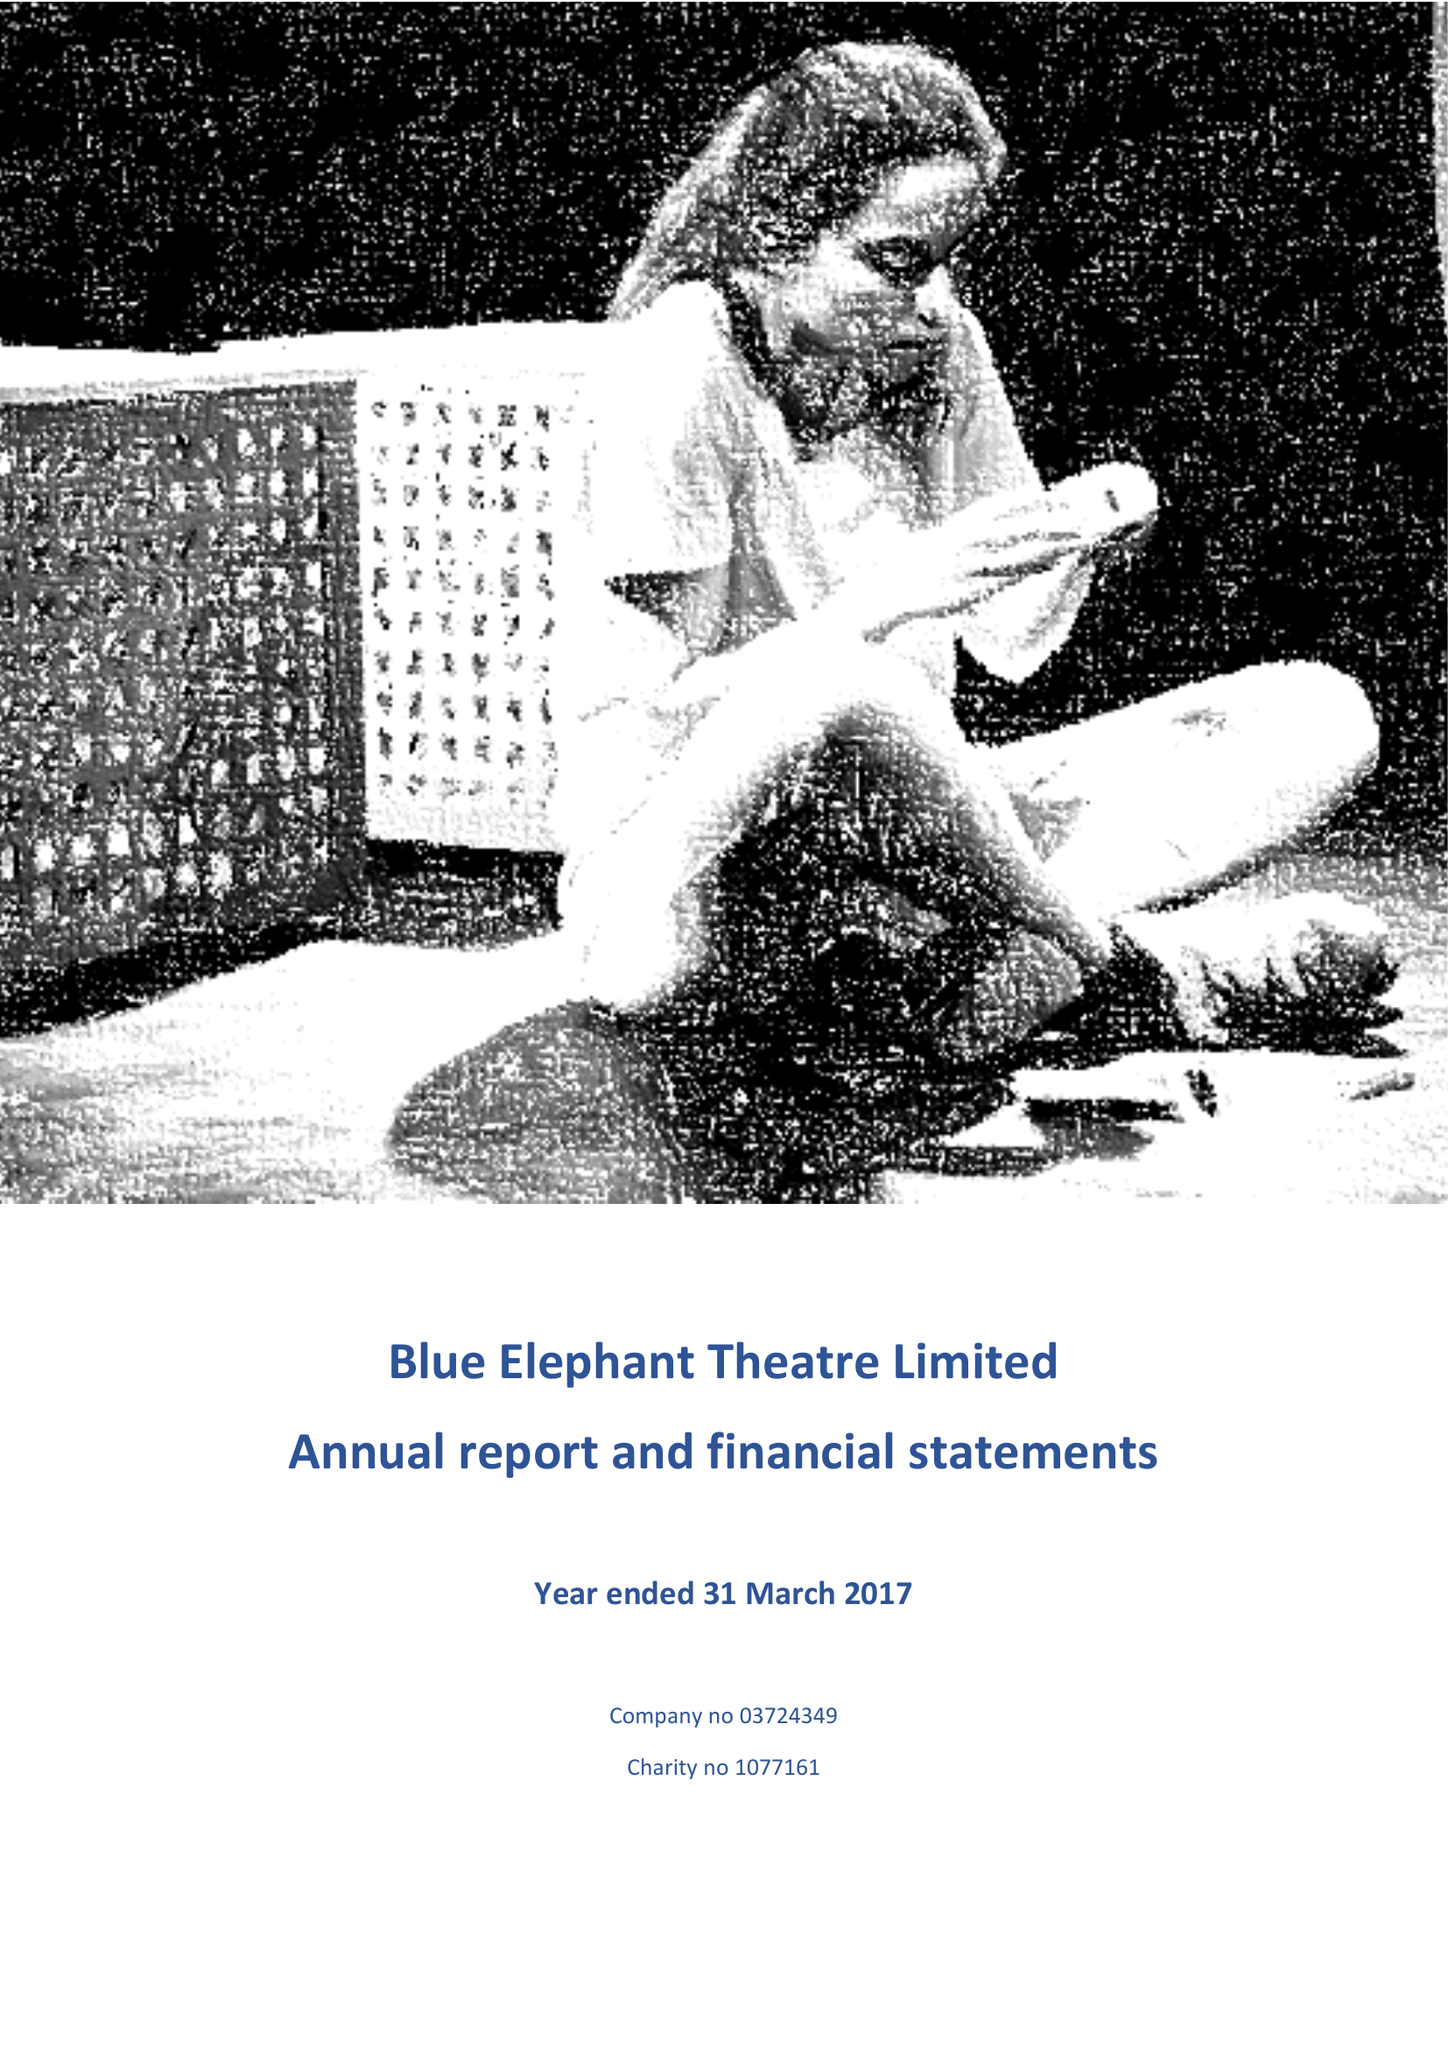What is the value for the income_annually_in_british_pounds?
Answer the question using a single word or phrase. 142292.00 